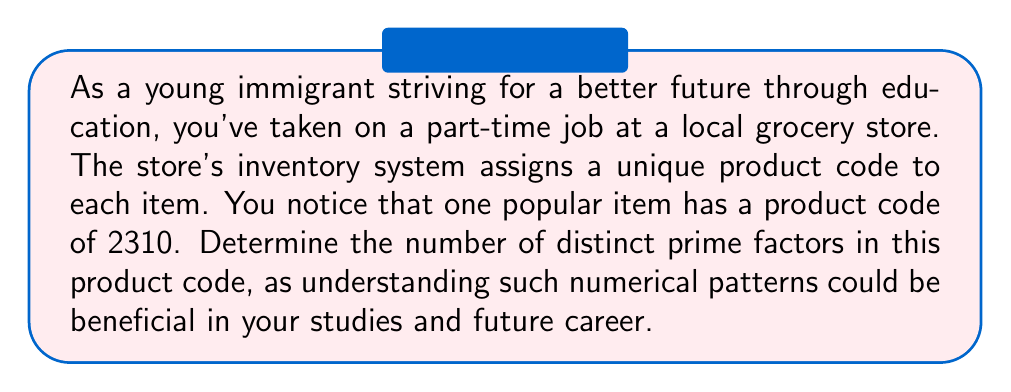Teach me how to tackle this problem. To find the number of distinct prime factors in 2310, we need to break down this number into its prime factors. Let's approach this step-by-step:

1) First, let's find the smallest prime factor of 2310:
   $2310 = 2 \times 1155$

2) Now, let's continue factoring 1155:
   $1155 = 3 \times 385$

3) Factoring 385:
   $385 = 5 \times 77$

4) Factoring 77:
   $77 = 7 \times 11$

5) Now we have completely factored 2310:
   $2310 = 2 \times 3 \times 5 \times 7 \times 11$

6) We can write this as:
   $2310 = 2^1 \times 3^1 \times 5^1 \times 7^1 \times 11^1$

7) To count the number of distinct prime factors, we simply need to count how many different primes appear in this factorization, regardless of their exponents.

Therefore, the distinct prime factors are 2, 3, 5, 7, and 11.
Answer: The number of distinct prime factors in 2310 is 5. 